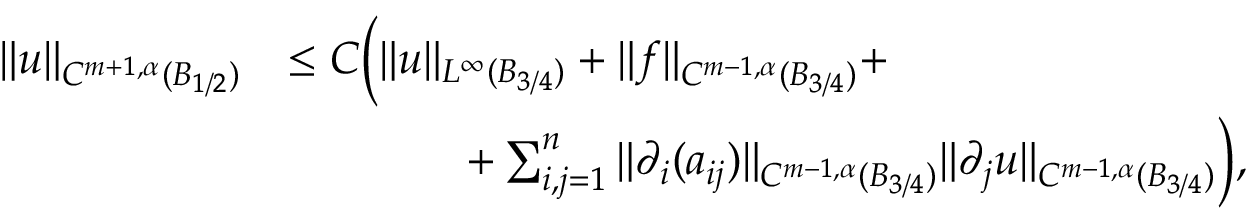Convert formula to latex. <formula><loc_0><loc_0><loc_500><loc_500>\begin{array} { r l } { \| u \| _ { C ^ { m + 1 , \alpha } ( B _ { 1 / 2 } ) } } & { \leq C \left ( \| u \| _ { L ^ { \infty } ( B _ { 3 / 4 } ) } + \| f \| _ { C ^ { m - 1 , \alpha } ( B _ { 3 / 4 } ) } + } \\ & { \quad + \sum _ { i , j = 1 } ^ { n } \| \partial _ { i } ( a _ { i j } ) \| _ { C ^ { m - 1 , \alpha } ( B _ { 3 / 4 } ) } \| \partial _ { j } u \| _ { C ^ { m - 1 , \alpha } ( B _ { 3 / 4 } ) } \right ) , } \end{array}</formula> 